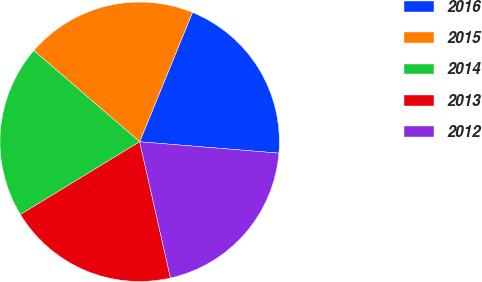Convert chart. <chart><loc_0><loc_0><loc_500><loc_500><pie_chart><fcel>2016<fcel>2015<fcel>2014<fcel>2013<fcel>2012<nl><fcel>20.13%<fcel>19.85%<fcel>20.04%<fcel>19.82%<fcel>20.16%<nl></chart> 